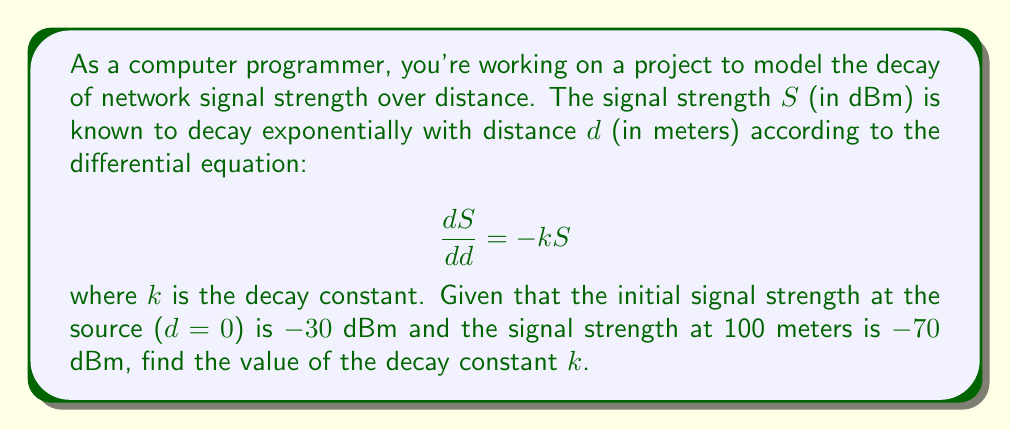Solve this math problem. To solve this problem, we'll follow these steps:

1) The general solution to the given differential equation is:
   $$S = Ce^{-kd}$$
   where $C$ is a constant we need to determine.

2) Using the initial condition: at $d=0$, $S=-30$ dBm
   $$-30 = Ce^{-k(0)} = C$$

3) Now we have the specific solution:
   $$S = -30e^{-kd}$$

4) Using the second condition: at $d=100$, $S=-70$ dBm
   $$-70 = -30e^{-k(100)}$$

5) Dividing both sides by -30:
   $$\frac{70}{30} = e^{-k(100)}$$

6) Taking the natural log of both sides:
   $$\ln(\frac{70}{30}) = -100k$$

7) Solving for $k$:
   $$k = -\frac{1}{100}\ln(\frac{70}{30}) = \frac{1}{100}\ln(\frac{30}{70})$$

8) Calculate the value:
   $$k \approx 0.0085$$

This approach, using a mathematical model to describe a physical phenomenon, demonstrates how science can be reduced to logical computations, aligning with a programmer's perspective.
Answer: $k \approx 0.0085$ m^(-1) 